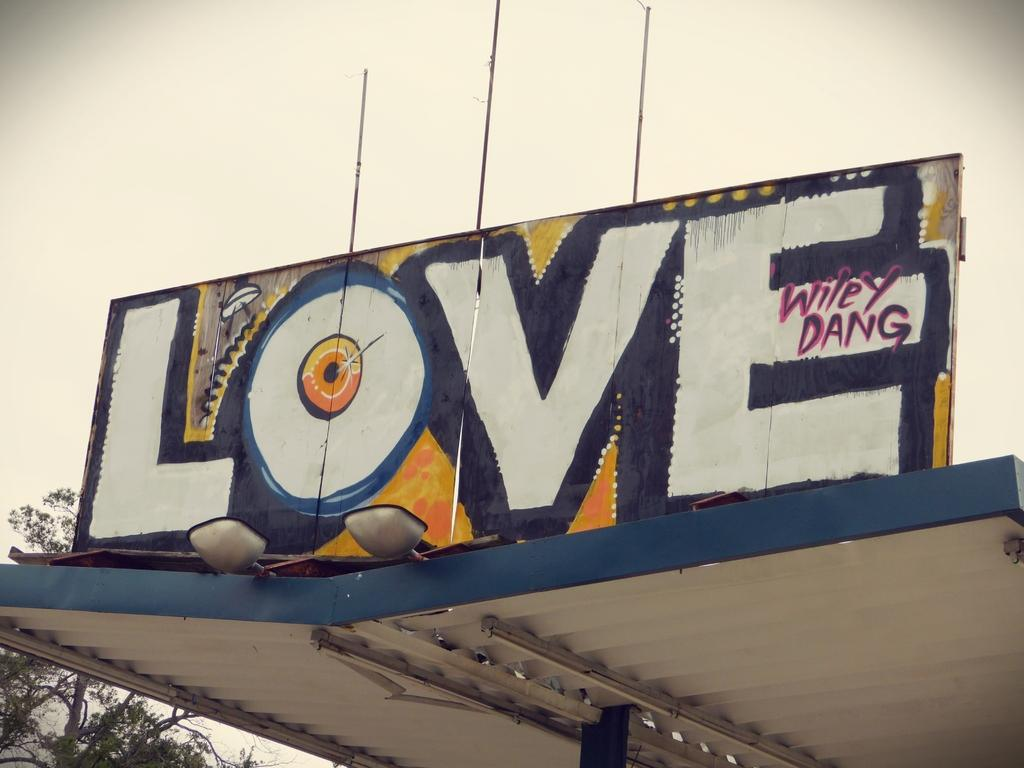<image>
Provide a brief description of the given image. The graphitti are is by an artist called Wiley Dang 